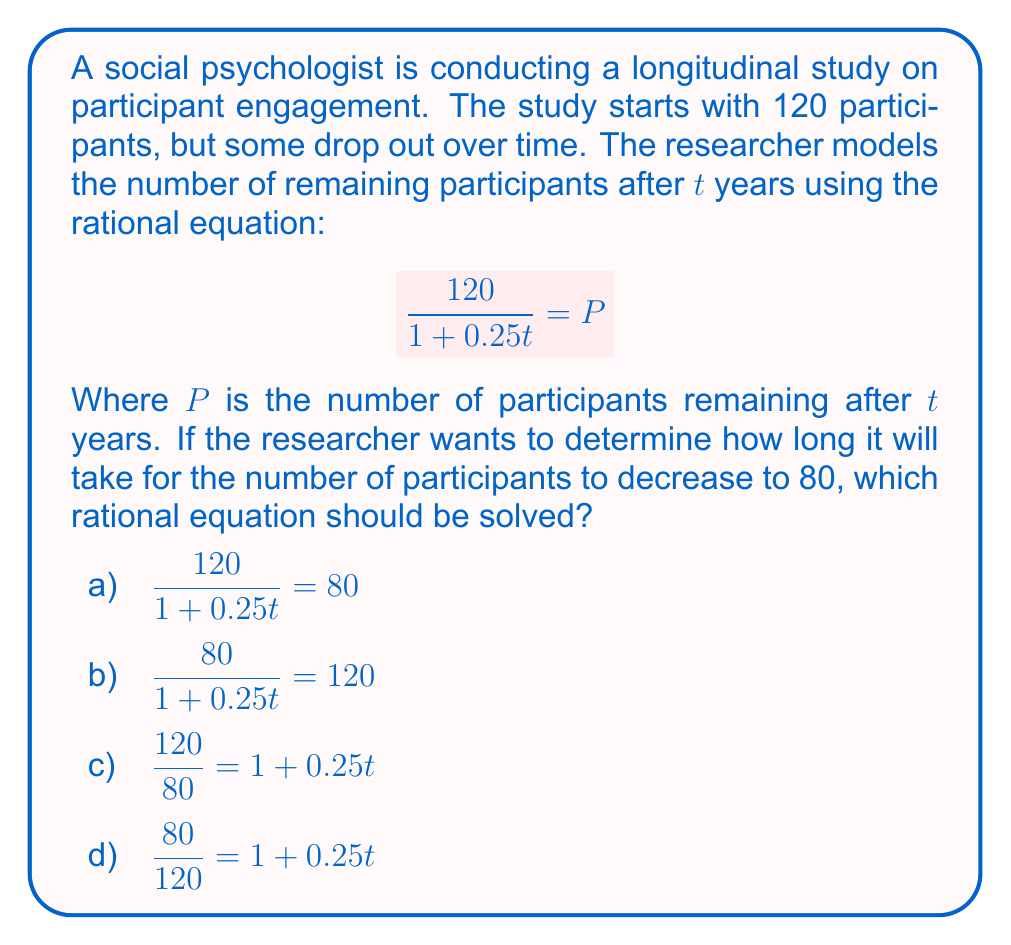Show me your answer to this math problem. To solve this problem, we need to understand the given rational equation and how to manipulate it to find the time t when the number of participants P equals 80.

Step 1: Identify the correct equation
The original equation is $$\frac{120}{1 + 0.25t} = P$$
We want to find t when P = 80, so we substitute 80 for P:
$$\frac{120}{1 + 0.25t} = 80$$

This matches option a), which is the correct equation to solve.

Step 2: Solve the equation
To solve this rational equation:

1) Multiply both sides by (1 + 0.25t):
   $120 = 80(1 + 0.25t)$

2) Distribute on the right side:
   $120 = 80 + 20t$

3) Subtract 80 from both sides:
   $40 = 20t$

4) Divide both sides by 20:
   $2 = t$

Therefore, it will take 2 years for the number of participants to decrease to 80.

The other options are incorrect because:
b) Reverses the numerator and denominator
c) and d) Incorrectly manipulate the equation
Answer: a) $$\frac{120}{1 + 0.25t} = 80$$ 